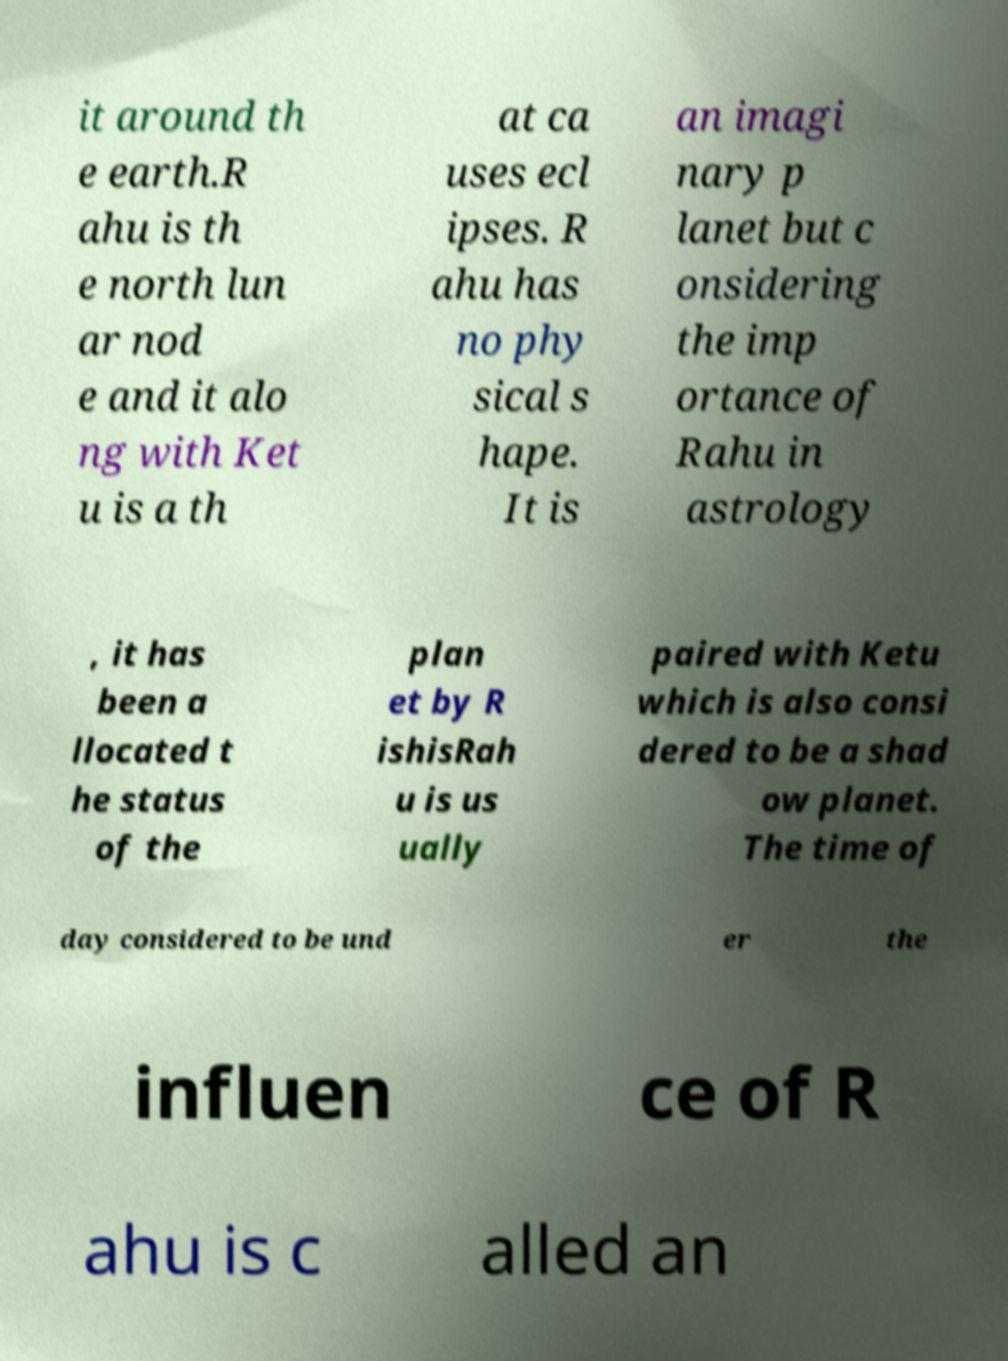Please identify and transcribe the text found in this image. it around th e earth.R ahu is th e north lun ar nod e and it alo ng with Ket u is a th at ca uses ecl ipses. R ahu has no phy sical s hape. It is an imagi nary p lanet but c onsidering the imp ortance of Rahu in astrology , it has been a llocated t he status of the plan et by R ishisRah u is us ually paired with Ketu which is also consi dered to be a shad ow planet. The time of day considered to be und er the influen ce of R ahu is c alled an 